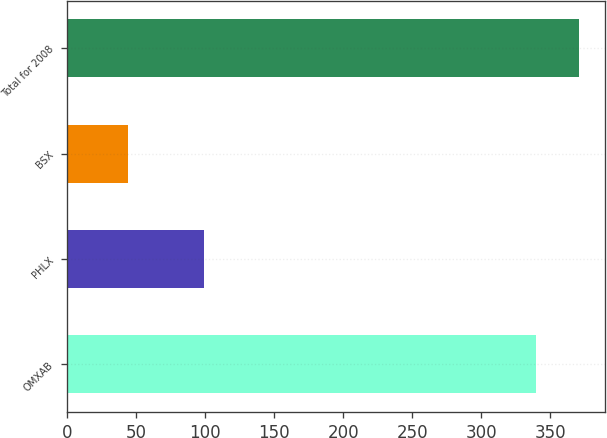Convert chart to OTSL. <chart><loc_0><loc_0><loc_500><loc_500><bar_chart><fcel>OMXAB<fcel>PHLX<fcel>BSX<fcel>Total for 2008<nl><fcel>340<fcel>99<fcel>44<fcel>371.2<nl></chart> 